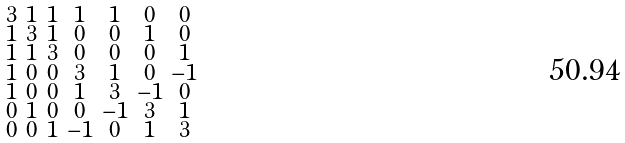<formula> <loc_0><loc_0><loc_500><loc_500>\begin{smallmatrix} 3 & 1 & 1 & 1 & 1 & 0 & 0 \\ 1 & 3 & 1 & 0 & 0 & 1 & 0 \\ 1 & 1 & 3 & 0 & 0 & 0 & 1 \\ 1 & 0 & 0 & 3 & 1 & 0 & - 1 \\ 1 & 0 & 0 & 1 & 3 & - 1 & 0 \\ 0 & 1 & 0 & 0 & - 1 & 3 & 1 \\ 0 & 0 & 1 & - 1 & 0 & 1 & 3 \end{smallmatrix}</formula> 